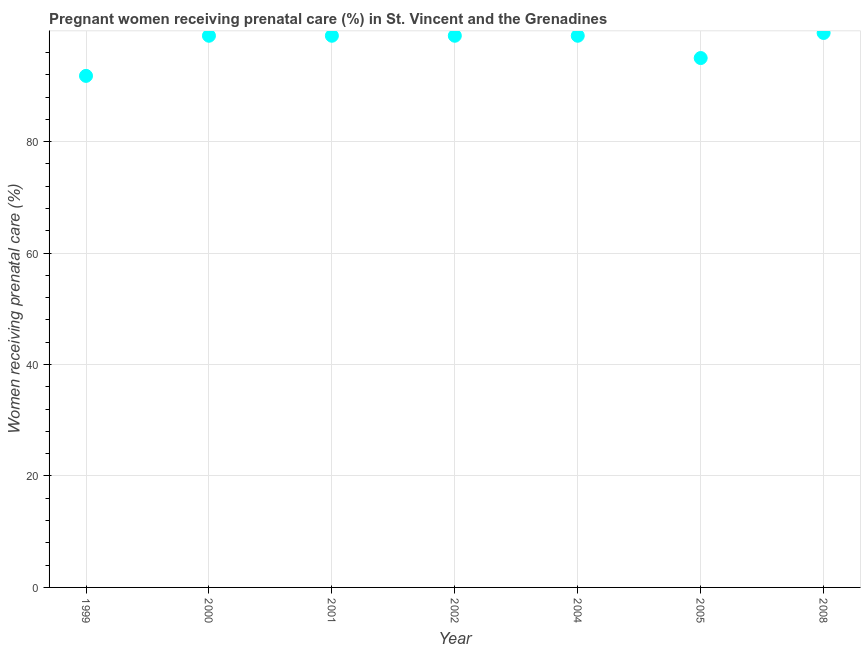What is the percentage of pregnant women receiving prenatal care in 2002?
Offer a terse response. 99. Across all years, what is the maximum percentage of pregnant women receiving prenatal care?
Ensure brevity in your answer.  99.5. Across all years, what is the minimum percentage of pregnant women receiving prenatal care?
Your response must be concise. 91.8. What is the sum of the percentage of pregnant women receiving prenatal care?
Provide a succinct answer. 682.3. What is the difference between the percentage of pregnant women receiving prenatal care in 2005 and 2008?
Make the answer very short. -4.5. What is the average percentage of pregnant women receiving prenatal care per year?
Ensure brevity in your answer.  97.47. Do a majority of the years between 2002 and 2005 (inclusive) have percentage of pregnant women receiving prenatal care greater than 48 %?
Provide a short and direct response. Yes. What is the ratio of the percentage of pregnant women receiving prenatal care in 2000 to that in 2004?
Offer a very short reply. 1. Is the percentage of pregnant women receiving prenatal care in 1999 less than that in 2004?
Ensure brevity in your answer.  Yes. What is the difference between the highest and the second highest percentage of pregnant women receiving prenatal care?
Give a very brief answer. 0.5. Is the sum of the percentage of pregnant women receiving prenatal care in 1999 and 2005 greater than the maximum percentage of pregnant women receiving prenatal care across all years?
Your answer should be very brief. Yes. What is the difference between the highest and the lowest percentage of pregnant women receiving prenatal care?
Ensure brevity in your answer.  7.7. Are the values on the major ticks of Y-axis written in scientific E-notation?
Give a very brief answer. No. Does the graph contain any zero values?
Offer a terse response. No. Does the graph contain grids?
Offer a terse response. Yes. What is the title of the graph?
Your answer should be compact. Pregnant women receiving prenatal care (%) in St. Vincent and the Grenadines. What is the label or title of the X-axis?
Your response must be concise. Year. What is the label or title of the Y-axis?
Give a very brief answer. Women receiving prenatal care (%). What is the Women receiving prenatal care (%) in 1999?
Your answer should be compact. 91.8. What is the Women receiving prenatal care (%) in 2001?
Make the answer very short. 99. What is the Women receiving prenatal care (%) in 2002?
Provide a succinct answer. 99. What is the Women receiving prenatal care (%) in 2005?
Provide a succinct answer. 95. What is the Women receiving prenatal care (%) in 2008?
Give a very brief answer. 99.5. What is the difference between the Women receiving prenatal care (%) in 1999 and 2002?
Provide a short and direct response. -7.2. What is the difference between the Women receiving prenatal care (%) in 1999 and 2004?
Give a very brief answer. -7.2. What is the difference between the Women receiving prenatal care (%) in 2000 and 2004?
Your response must be concise. 0. What is the difference between the Women receiving prenatal care (%) in 2001 and 2002?
Make the answer very short. 0. What is the difference between the Women receiving prenatal care (%) in 2001 and 2004?
Ensure brevity in your answer.  0. What is the difference between the Women receiving prenatal care (%) in 2001 and 2005?
Your response must be concise. 4. What is the difference between the Women receiving prenatal care (%) in 2002 and 2008?
Ensure brevity in your answer.  -0.5. What is the ratio of the Women receiving prenatal care (%) in 1999 to that in 2000?
Give a very brief answer. 0.93. What is the ratio of the Women receiving prenatal care (%) in 1999 to that in 2001?
Make the answer very short. 0.93. What is the ratio of the Women receiving prenatal care (%) in 1999 to that in 2002?
Provide a succinct answer. 0.93. What is the ratio of the Women receiving prenatal care (%) in 1999 to that in 2004?
Ensure brevity in your answer.  0.93. What is the ratio of the Women receiving prenatal care (%) in 1999 to that in 2008?
Your response must be concise. 0.92. What is the ratio of the Women receiving prenatal care (%) in 2000 to that in 2001?
Make the answer very short. 1. What is the ratio of the Women receiving prenatal care (%) in 2000 to that in 2002?
Provide a succinct answer. 1. What is the ratio of the Women receiving prenatal care (%) in 2000 to that in 2005?
Provide a short and direct response. 1.04. What is the ratio of the Women receiving prenatal care (%) in 2000 to that in 2008?
Give a very brief answer. 0.99. What is the ratio of the Women receiving prenatal care (%) in 2001 to that in 2005?
Keep it short and to the point. 1.04. What is the ratio of the Women receiving prenatal care (%) in 2001 to that in 2008?
Ensure brevity in your answer.  0.99. What is the ratio of the Women receiving prenatal care (%) in 2002 to that in 2005?
Make the answer very short. 1.04. What is the ratio of the Women receiving prenatal care (%) in 2002 to that in 2008?
Your response must be concise. 0.99. What is the ratio of the Women receiving prenatal care (%) in 2004 to that in 2005?
Ensure brevity in your answer.  1.04. What is the ratio of the Women receiving prenatal care (%) in 2005 to that in 2008?
Provide a succinct answer. 0.95. 